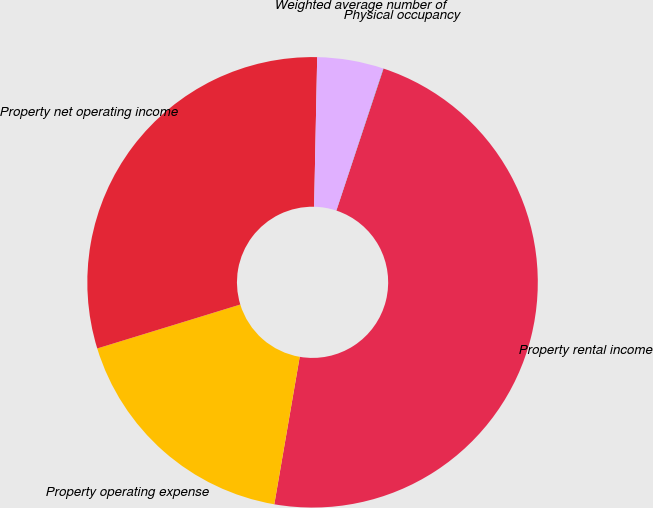Convert chart. <chart><loc_0><loc_0><loc_500><loc_500><pie_chart><fcel>Property rental income<fcel>Property operating expense<fcel>Property net operating income<fcel>Weighted average number of<fcel>Physical occupancy<nl><fcel>47.61%<fcel>17.54%<fcel>30.07%<fcel>4.77%<fcel>0.01%<nl></chart> 